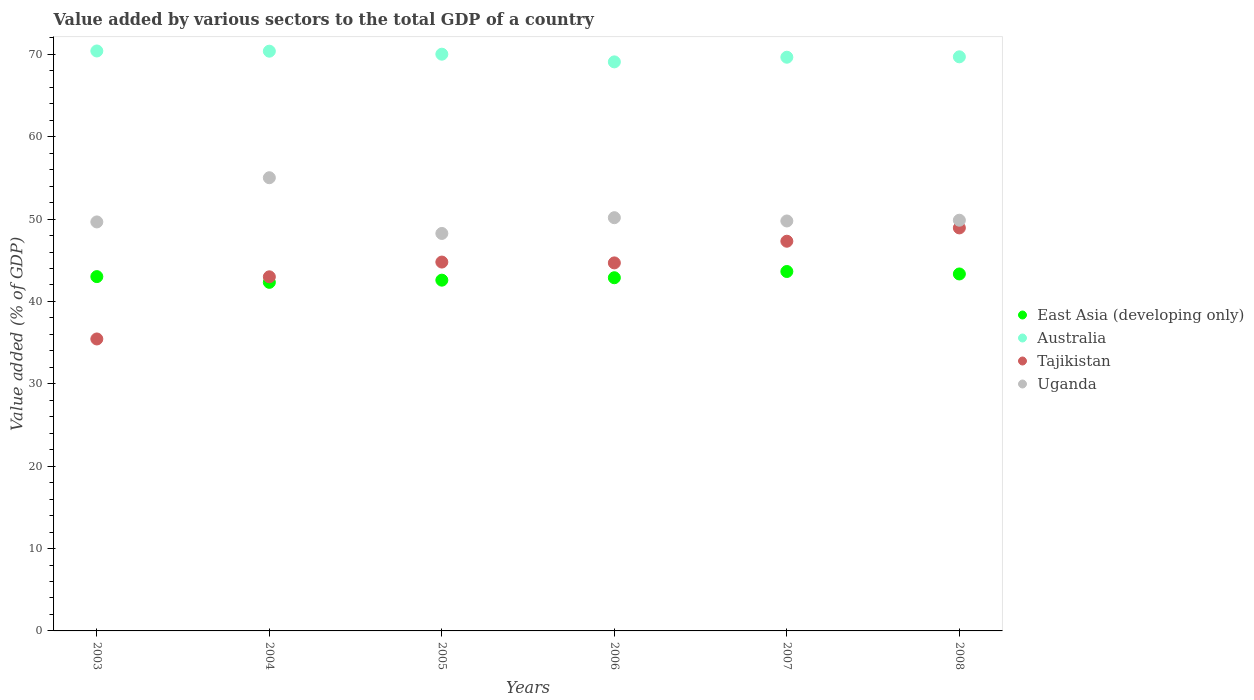What is the value added by various sectors to the total GDP in Tajikistan in 2008?
Offer a very short reply. 48.93. Across all years, what is the maximum value added by various sectors to the total GDP in Australia?
Give a very brief answer. 70.41. Across all years, what is the minimum value added by various sectors to the total GDP in East Asia (developing only)?
Provide a succinct answer. 42.32. What is the total value added by various sectors to the total GDP in Tajikistan in the graph?
Offer a terse response. 264.15. What is the difference between the value added by various sectors to the total GDP in Australia in 2004 and that in 2005?
Offer a very short reply. 0.36. What is the difference between the value added by various sectors to the total GDP in East Asia (developing only) in 2006 and the value added by various sectors to the total GDP in Tajikistan in 2005?
Ensure brevity in your answer.  -1.9. What is the average value added by various sectors to the total GDP in Uganda per year?
Give a very brief answer. 50.46. In the year 2005, what is the difference between the value added by various sectors to the total GDP in East Asia (developing only) and value added by various sectors to the total GDP in Australia?
Make the answer very short. -27.44. What is the ratio of the value added by various sectors to the total GDP in Uganda in 2003 to that in 2004?
Your answer should be compact. 0.9. Is the difference between the value added by various sectors to the total GDP in East Asia (developing only) in 2005 and 2007 greater than the difference between the value added by various sectors to the total GDP in Australia in 2005 and 2007?
Offer a terse response. No. What is the difference between the highest and the second highest value added by various sectors to the total GDP in East Asia (developing only)?
Offer a terse response. 0.3. What is the difference between the highest and the lowest value added by various sectors to the total GDP in Australia?
Your answer should be compact. 1.32. In how many years, is the value added by various sectors to the total GDP in Tajikistan greater than the average value added by various sectors to the total GDP in Tajikistan taken over all years?
Give a very brief answer. 4. Is it the case that in every year, the sum of the value added by various sectors to the total GDP in Uganda and value added by various sectors to the total GDP in Australia  is greater than the sum of value added by various sectors to the total GDP in East Asia (developing only) and value added by various sectors to the total GDP in Tajikistan?
Offer a very short reply. No. Is it the case that in every year, the sum of the value added by various sectors to the total GDP in Australia and value added by various sectors to the total GDP in Uganda  is greater than the value added by various sectors to the total GDP in East Asia (developing only)?
Your answer should be compact. Yes. Does the value added by various sectors to the total GDP in Australia monotonically increase over the years?
Offer a terse response. No. Is the value added by various sectors to the total GDP in East Asia (developing only) strictly less than the value added by various sectors to the total GDP in Tajikistan over the years?
Your response must be concise. No. How many dotlines are there?
Keep it short and to the point. 4. How many years are there in the graph?
Offer a very short reply. 6. Are the values on the major ticks of Y-axis written in scientific E-notation?
Make the answer very short. No. Does the graph contain grids?
Offer a terse response. No. How many legend labels are there?
Your answer should be very brief. 4. How are the legend labels stacked?
Provide a short and direct response. Vertical. What is the title of the graph?
Offer a terse response. Value added by various sectors to the total GDP of a country. What is the label or title of the Y-axis?
Offer a very short reply. Value added (% of GDP). What is the Value added (% of GDP) of East Asia (developing only) in 2003?
Provide a short and direct response. 43.02. What is the Value added (% of GDP) of Australia in 2003?
Provide a succinct answer. 70.41. What is the Value added (% of GDP) of Tajikistan in 2003?
Provide a short and direct response. 35.45. What is the Value added (% of GDP) in Uganda in 2003?
Give a very brief answer. 49.66. What is the Value added (% of GDP) in East Asia (developing only) in 2004?
Provide a short and direct response. 42.32. What is the Value added (% of GDP) in Australia in 2004?
Your response must be concise. 70.39. What is the Value added (% of GDP) in Tajikistan in 2004?
Provide a succinct answer. 42.99. What is the Value added (% of GDP) in Uganda in 2004?
Provide a succinct answer. 55.02. What is the Value added (% of GDP) of East Asia (developing only) in 2005?
Keep it short and to the point. 42.59. What is the Value added (% of GDP) in Australia in 2005?
Make the answer very short. 70.02. What is the Value added (% of GDP) of Tajikistan in 2005?
Your response must be concise. 44.78. What is the Value added (% of GDP) of Uganda in 2005?
Make the answer very short. 48.26. What is the Value added (% of GDP) in East Asia (developing only) in 2006?
Your answer should be compact. 42.88. What is the Value added (% of GDP) in Australia in 2006?
Your answer should be very brief. 69.09. What is the Value added (% of GDP) in Tajikistan in 2006?
Provide a succinct answer. 44.68. What is the Value added (% of GDP) in Uganda in 2006?
Offer a terse response. 50.17. What is the Value added (% of GDP) in East Asia (developing only) in 2007?
Your answer should be very brief. 43.64. What is the Value added (% of GDP) in Australia in 2007?
Your answer should be very brief. 69.65. What is the Value added (% of GDP) in Tajikistan in 2007?
Provide a short and direct response. 47.31. What is the Value added (% of GDP) in Uganda in 2007?
Offer a terse response. 49.77. What is the Value added (% of GDP) of East Asia (developing only) in 2008?
Your answer should be compact. 43.34. What is the Value added (% of GDP) of Australia in 2008?
Provide a short and direct response. 69.7. What is the Value added (% of GDP) in Tajikistan in 2008?
Your answer should be very brief. 48.93. What is the Value added (% of GDP) in Uganda in 2008?
Your answer should be very brief. 49.86. Across all years, what is the maximum Value added (% of GDP) of East Asia (developing only)?
Your answer should be very brief. 43.64. Across all years, what is the maximum Value added (% of GDP) of Australia?
Provide a succinct answer. 70.41. Across all years, what is the maximum Value added (% of GDP) of Tajikistan?
Your answer should be very brief. 48.93. Across all years, what is the maximum Value added (% of GDP) of Uganda?
Provide a succinct answer. 55.02. Across all years, what is the minimum Value added (% of GDP) in East Asia (developing only)?
Your response must be concise. 42.32. Across all years, what is the minimum Value added (% of GDP) of Australia?
Provide a short and direct response. 69.09. Across all years, what is the minimum Value added (% of GDP) in Tajikistan?
Give a very brief answer. 35.45. Across all years, what is the minimum Value added (% of GDP) in Uganda?
Give a very brief answer. 48.26. What is the total Value added (% of GDP) in East Asia (developing only) in the graph?
Ensure brevity in your answer.  257.78. What is the total Value added (% of GDP) in Australia in the graph?
Keep it short and to the point. 419.26. What is the total Value added (% of GDP) of Tajikistan in the graph?
Offer a terse response. 264.15. What is the total Value added (% of GDP) in Uganda in the graph?
Offer a very short reply. 302.74. What is the difference between the Value added (% of GDP) of East Asia (developing only) in 2003 and that in 2004?
Provide a short and direct response. 0.7. What is the difference between the Value added (% of GDP) in Australia in 2003 and that in 2004?
Ensure brevity in your answer.  0.03. What is the difference between the Value added (% of GDP) in Tajikistan in 2003 and that in 2004?
Your answer should be compact. -7.55. What is the difference between the Value added (% of GDP) in Uganda in 2003 and that in 2004?
Provide a succinct answer. -5.37. What is the difference between the Value added (% of GDP) of East Asia (developing only) in 2003 and that in 2005?
Ensure brevity in your answer.  0.43. What is the difference between the Value added (% of GDP) in Australia in 2003 and that in 2005?
Make the answer very short. 0.39. What is the difference between the Value added (% of GDP) in Tajikistan in 2003 and that in 2005?
Offer a terse response. -9.34. What is the difference between the Value added (% of GDP) in Uganda in 2003 and that in 2005?
Your response must be concise. 1.4. What is the difference between the Value added (% of GDP) in East Asia (developing only) in 2003 and that in 2006?
Your response must be concise. 0.14. What is the difference between the Value added (% of GDP) of Australia in 2003 and that in 2006?
Keep it short and to the point. 1.32. What is the difference between the Value added (% of GDP) of Tajikistan in 2003 and that in 2006?
Offer a terse response. -9.24. What is the difference between the Value added (% of GDP) of Uganda in 2003 and that in 2006?
Ensure brevity in your answer.  -0.51. What is the difference between the Value added (% of GDP) of East Asia (developing only) in 2003 and that in 2007?
Provide a succinct answer. -0.62. What is the difference between the Value added (% of GDP) in Australia in 2003 and that in 2007?
Your answer should be very brief. 0.76. What is the difference between the Value added (% of GDP) in Tajikistan in 2003 and that in 2007?
Offer a very short reply. -11.87. What is the difference between the Value added (% of GDP) in Uganda in 2003 and that in 2007?
Your answer should be compact. -0.12. What is the difference between the Value added (% of GDP) of East Asia (developing only) in 2003 and that in 2008?
Offer a terse response. -0.32. What is the difference between the Value added (% of GDP) in Australia in 2003 and that in 2008?
Your answer should be very brief. 0.71. What is the difference between the Value added (% of GDP) of Tajikistan in 2003 and that in 2008?
Offer a terse response. -13.48. What is the difference between the Value added (% of GDP) in Uganda in 2003 and that in 2008?
Provide a succinct answer. -0.21. What is the difference between the Value added (% of GDP) in East Asia (developing only) in 2004 and that in 2005?
Your response must be concise. -0.27. What is the difference between the Value added (% of GDP) of Australia in 2004 and that in 2005?
Give a very brief answer. 0.36. What is the difference between the Value added (% of GDP) of Tajikistan in 2004 and that in 2005?
Give a very brief answer. -1.79. What is the difference between the Value added (% of GDP) in Uganda in 2004 and that in 2005?
Offer a very short reply. 6.76. What is the difference between the Value added (% of GDP) of East Asia (developing only) in 2004 and that in 2006?
Your answer should be very brief. -0.56. What is the difference between the Value added (% of GDP) in Australia in 2004 and that in 2006?
Offer a terse response. 1.3. What is the difference between the Value added (% of GDP) of Tajikistan in 2004 and that in 2006?
Offer a terse response. -1.69. What is the difference between the Value added (% of GDP) of Uganda in 2004 and that in 2006?
Provide a succinct answer. 4.85. What is the difference between the Value added (% of GDP) of East Asia (developing only) in 2004 and that in 2007?
Your answer should be compact. -1.32. What is the difference between the Value added (% of GDP) in Australia in 2004 and that in 2007?
Offer a terse response. 0.73. What is the difference between the Value added (% of GDP) of Tajikistan in 2004 and that in 2007?
Offer a very short reply. -4.32. What is the difference between the Value added (% of GDP) of Uganda in 2004 and that in 2007?
Offer a very short reply. 5.25. What is the difference between the Value added (% of GDP) in East Asia (developing only) in 2004 and that in 2008?
Your answer should be very brief. -1.02. What is the difference between the Value added (% of GDP) in Australia in 2004 and that in 2008?
Make the answer very short. 0.68. What is the difference between the Value added (% of GDP) of Tajikistan in 2004 and that in 2008?
Give a very brief answer. -5.94. What is the difference between the Value added (% of GDP) of Uganda in 2004 and that in 2008?
Give a very brief answer. 5.16. What is the difference between the Value added (% of GDP) of East Asia (developing only) in 2005 and that in 2006?
Make the answer very short. -0.29. What is the difference between the Value added (% of GDP) in Australia in 2005 and that in 2006?
Your answer should be very brief. 0.93. What is the difference between the Value added (% of GDP) of Tajikistan in 2005 and that in 2006?
Offer a very short reply. 0.1. What is the difference between the Value added (% of GDP) of Uganda in 2005 and that in 2006?
Give a very brief answer. -1.91. What is the difference between the Value added (% of GDP) of East Asia (developing only) in 2005 and that in 2007?
Make the answer very short. -1.05. What is the difference between the Value added (% of GDP) of Australia in 2005 and that in 2007?
Offer a terse response. 0.37. What is the difference between the Value added (% of GDP) of Tajikistan in 2005 and that in 2007?
Your answer should be compact. -2.53. What is the difference between the Value added (% of GDP) in Uganda in 2005 and that in 2007?
Ensure brevity in your answer.  -1.52. What is the difference between the Value added (% of GDP) of East Asia (developing only) in 2005 and that in 2008?
Provide a succinct answer. -0.75. What is the difference between the Value added (% of GDP) of Australia in 2005 and that in 2008?
Provide a succinct answer. 0.32. What is the difference between the Value added (% of GDP) in Tajikistan in 2005 and that in 2008?
Ensure brevity in your answer.  -4.15. What is the difference between the Value added (% of GDP) in Uganda in 2005 and that in 2008?
Provide a succinct answer. -1.61. What is the difference between the Value added (% of GDP) of East Asia (developing only) in 2006 and that in 2007?
Provide a succinct answer. -0.76. What is the difference between the Value added (% of GDP) of Australia in 2006 and that in 2007?
Give a very brief answer. -0.56. What is the difference between the Value added (% of GDP) in Tajikistan in 2006 and that in 2007?
Offer a terse response. -2.63. What is the difference between the Value added (% of GDP) in Uganda in 2006 and that in 2007?
Your answer should be compact. 0.4. What is the difference between the Value added (% of GDP) of East Asia (developing only) in 2006 and that in 2008?
Your answer should be very brief. -0.46. What is the difference between the Value added (% of GDP) in Australia in 2006 and that in 2008?
Your response must be concise. -0.61. What is the difference between the Value added (% of GDP) of Tajikistan in 2006 and that in 2008?
Your answer should be compact. -4.25. What is the difference between the Value added (% of GDP) in Uganda in 2006 and that in 2008?
Give a very brief answer. 0.31. What is the difference between the Value added (% of GDP) of East Asia (developing only) in 2007 and that in 2008?
Your answer should be very brief. 0.3. What is the difference between the Value added (% of GDP) in Australia in 2007 and that in 2008?
Your answer should be very brief. -0.05. What is the difference between the Value added (% of GDP) of Tajikistan in 2007 and that in 2008?
Offer a very short reply. -1.62. What is the difference between the Value added (% of GDP) in Uganda in 2007 and that in 2008?
Your answer should be very brief. -0.09. What is the difference between the Value added (% of GDP) in East Asia (developing only) in 2003 and the Value added (% of GDP) in Australia in 2004?
Provide a succinct answer. -27.37. What is the difference between the Value added (% of GDP) of East Asia (developing only) in 2003 and the Value added (% of GDP) of Tajikistan in 2004?
Offer a very short reply. 0.03. What is the difference between the Value added (% of GDP) in East Asia (developing only) in 2003 and the Value added (% of GDP) in Uganda in 2004?
Offer a very short reply. -12. What is the difference between the Value added (% of GDP) in Australia in 2003 and the Value added (% of GDP) in Tajikistan in 2004?
Ensure brevity in your answer.  27.42. What is the difference between the Value added (% of GDP) in Australia in 2003 and the Value added (% of GDP) in Uganda in 2004?
Provide a succinct answer. 15.39. What is the difference between the Value added (% of GDP) in Tajikistan in 2003 and the Value added (% of GDP) in Uganda in 2004?
Make the answer very short. -19.58. What is the difference between the Value added (% of GDP) in East Asia (developing only) in 2003 and the Value added (% of GDP) in Australia in 2005?
Keep it short and to the point. -27. What is the difference between the Value added (% of GDP) in East Asia (developing only) in 2003 and the Value added (% of GDP) in Tajikistan in 2005?
Your response must be concise. -1.77. What is the difference between the Value added (% of GDP) of East Asia (developing only) in 2003 and the Value added (% of GDP) of Uganda in 2005?
Your response must be concise. -5.24. What is the difference between the Value added (% of GDP) in Australia in 2003 and the Value added (% of GDP) in Tajikistan in 2005?
Offer a terse response. 25.63. What is the difference between the Value added (% of GDP) in Australia in 2003 and the Value added (% of GDP) in Uganda in 2005?
Offer a very short reply. 22.15. What is the difference between the Value added (% of GDP) in Tajikistan in 2003 and the Value added (% of GDP) in Uganda in 2005?
Provide a succinct answer. -12.81. What is the difference between the Value added (% of GDP) in East Asia (developing only) in 2003 and the Value added (% of GDP) in Australia in 2006?
Give a very brief answer. -26.07. What is the difference between the Value added (% of GDP) of East Asia (developing only) in 2003 and the Value added (% of GDP) of Tajikistan in 2006?
Offer a terse response. -1.66. What is the difference between the Value added (% of GDP) in East Asia (developing only) in 2003 and the Value added (% of GDP) in Uganda in 2006?
Make the answer very short. -7.15. What is the difference between the Value added (% of GDP) in Australia in 2003 and the Value added (% of GDP) in Tajikistan in 2006?
Ensure brevity in your answer.  25.73. What is the difference between the Value added (% of GDP) of Australia in 2003 and the Value added (% of GDP) of Uganda in 2006?
Offer a very short reply. 20.24. What is the difference between the Value added (% of GDP) of Tajikistan in 2003 and the Value added (% of GDP) of Uganda in 2006?
Ensure brevity in your answer.  -14.72. What is the difference between the Value added (% of GDP) of East Asia (developing only) in 2003 and the Value added (% of GDP) of Australia in 2007?
Make the answer very short. -26.64. What is the difference between the Value added (% of GDP) of East Asia (developing only) in 2003 and the Value added (% of GDP) of Tajikistan in 2007?
Ensure brevity in your answer.  -4.3. What is the difference between the Value added (% of GDP) of East Asia (developing only) in 2003 and the Value added (% of GDP) of Uganda in 2007?
Offer a very short reply. -6.76. What is the difference between the Value added (% of GDP) in Australia in 2003 and the Value added (% of GDP) in Tajikistan in 2007?
Your answer should be compact. 23.1. What is the difference between the Value added (% of GDP) of Australia in 2003 and the Value added (% of GDP) of Uganda in 2007?
Provide a short and direct response. 20.64. What is the difference between the Value added (% of GDP) of Tajikistan in 2003 and the Value added (% of GDP) of Uganda in 2007?
Keep it short and to the point. -14.33. What is the difference between the Value added (% of GDP) in East Asia (developing only) in 2003 and the Value added (% of GDP) in Australia in 2008?
Provide a short and direct response. -26.68. What is the difference between the Value added (% of GDP) in East Asia (developing only) in 2003 and the Value added (% of GDP) in Tajikistan in 2008?
Ensure brevity in your answer.  -5.91. What is the difference between the Value added (% of GDP) of East Asia (developing only) in 2003 and the Value added (% of GDP) of Uganda in 2008?
Give a very brief answer. -6.85. What is the difference between the Value added (% of GDP) in Australia in 2003 and the Value added (% of GDP) in Tajikistan in 2008?
Make the answer very short. 21.48. What is the difference between the Value added (% of GDP) of Australia in 2003 and the Value added (% of GDP) of Uganda in 2008?
Your answer should be compact. 20.55. What is the difference between the Value added (% of GDP) of Tajikistan in 2003 and the Value added (% of GDP) of Uganda in 2008?
Your response must be concise. -14.42. What is the difference between the Value added (% of GDP) of East Asia (developing only) in 2004 and the Value added (% of GDP) of Australia in 2005?
Give a very brief answer. -27.7. What is the difference between the Value added (% of GDP) in East Asia (developing only) in 2004 and the Value added (% of GDP) in Tajikistan in 2005?
Offer a terse response. -2.46. What is the difference between the Value added (% of GDP) in East Asia (developing only) in 2004 and the Value added (% of GDP) in Uganda in 2005?
Your answer should be very brief. -5.94. What is the difference between the Value added (% of GDP) in Australia in 2004 and the Value added (% of GDP) in Tajikistan in 2005?
Make the answer very short. 25.6. What is the difference between the Value added (% of GDP) in Australia in 2004 and the Value added (% of GDP) in Uganda in 2005?
Your answer should be very brief. 22.13. What is the difference between the Value added (% of GDP) in Tajikistan in 2004 and the Value added (% of GDP) in Uganda in 2005?
Provide a succinct answer. -5.27. What is the difference between the Value added (% of GDP) of East Asia (developing only) in 2004 and the Value added (% of GDP) of Australia in 2006?
Ensure brevity in your answer.  -26.77. What is the difference between the Value added (% of GDP) of East Asia (developing only) in 2004 and the Value added (% of GDP) of Tajikistan in 2006?
Keep it short and to the point. -2.36. What is the difference between the Value added (% of GDP) of East Asia (developing only) in 2004 and the Value added (% of GDP) of Uganda in 2006?
Give a very brief answer. -7.85. What is the difference between the Value added (% of GDP) in Australia in 2004 and the Value added (% of GDP) in Tajikistan in 2006?
Offer a very short reply. 25.7. What is the difference between the Value added (% of GDP) in Australia in 2004 and the Value added (% of GDP) in Uganda in 2006?
Offer a terse response. 20.22. What is the difference between the Value added (% of GDP) of Tajikistan in 2004 and the Value added (% of GDP) of Uganda in 2006?
Your answer should be compact. -7.18. What is the difference between the Value added (% of GDP) in East Asia (developing only) in 2004 and the Value added (% of GDP) in Australia in 2007?
Your answer should be compact. -27.33. What is the difference between the Value added (% of GDP) of East Asia (developing only) in 2004 and the Value added (% of GDP) of Tajikistan in 2007?
Offer a terse response. -4.99. What is the difference between the Value added (% of GDP) in East Asia (developing only) in 2004 and the Value added (% of GDP) in Uganda in 2007?
Your answer should be compact. -7.45. What is the difference between the Value added (% of GDP) in Australia in 2004 and the Value added (% of GDP) in Tajikistan in 2007?
Your response must be concise. 23.07. What is the difference between the Value added (% of GDP) of Australia in 2004 and the Value added (% of GDP) of Uganda in 2007?
Offer a very short reply. 20.61. What is the difference between the Value added (% of GDP) of Tajikistan in 2004 and the Value added (% of GDP) of Uganda in 2007?
Offer a terse response. -6.78. What is the difference between the Value added (% of GDP) in East Asia (developing only) in 2004 and the Value added (% of GDP) in Australia in 2008?
Keep it short and to the point. -27.38. What is the difference between the Value added (% of GDP) in East Asia (developing only) in 2004 and the Value added (% of GDP) in Tajikistan in 2008?
Keep it short and to the point. -6.61. What is the difference between the Value added (% of GDP) in East Asia (developing only) in 2004 and the Value added (% of GDP) in Uganda in 2008?
Your answer should be compact. -7.54. What is the difference between the Value added (% of GDP) in Australia in 2004 and the Value added (% of GDP) in Tajikistan in 2008?
Your answer should be very brief. 21.46. What is the difference between the Value added (% of GDP) in Australia in 2004 and the Value added (% of GDP) in Uganda in 2008?
Give a very brief answer. 20.52. What is the difference between the Value added (% of GDP) in Tajikistan in 2004 and the Value added (% of GDP) in Uganda in 2008?
Your response must be concise. -6.87. What is the difference between the Value added (% of GDP) in East Asia (developing only) in 2005 and the Value added (% of GDP) in Australia in 2006?
Offer a terse response. -26.5. What is the difference between the Value added (% of GDP) of East Asia (developing only) in 2005 and the Value added (% of GDP) of Tajikistan in 2006?
Your response must be concise. -2.1. What is the difference between the Value added (% of GDP) of East Asia (developing only) in 2005 and the Value added (% of GDP) of Uganda in 2006?
Ensure brevity in your answer.  -7.58. What is the difference between the Value added (% of GDP) in Australia in 2005 and the Value added (% of GDP) in Tajikistan in 2006?
Provide a succinct answer. 25.34. What is the difference between the Value added (% of GDP) of Australia in 2005 and the Value added (% of GDP) of Uganda in 2006?
Provide a short and direct response. 19.85. What is the difference between the Value added (% of GDP) of Tajikistan in 2005 and the Value added (% of GDP) of Uganda in 2006?
Your answer should be very brief. -5.39. What is the difference between the Value added (% of GDP) in East Asia (developing only) in 2005 and the Value added (% of GDP) in Australia in 2007?
Offer a very short reply. -27.07. What is the difference between the Value added (% of GDP) in East Asia (developing only) in 2005 and the Value added (% of GDP) in Tajikistan in 2007?
Keep it short and to the point. -4.73. What is the difference between the Value added (% of GDP) in East Asia (developing only) in 2005 and the Value added (% of GDP) in Uganda in 2007?
Your answer should be compact. -7.19. What is the difference between the Value added (% of GDP) in Australia in 2005 and the Value added (% of GDP) in Tajikistan in 2007?
Offer a very short reply. 22.71. What is the difference between the Value added (% of GDP) of Australia in 2005 and the Value added (% of GDP) of Uganda in 2007?
Make the answer very short. 20.25. What is the difference between the Value added (% of GDP) of Tajikistan in 2005 and the Value added (% of GDP) of Uganda in 2007?
Make the answer very short. -4.99. What is the difference between the Value added (% of GDP) in East Asia (developing only) in 2005 and the Value added (% of GDP) in Australia in 2008?
Provide a short and direct response. -27.12. What is the difference between the Value added (% of GDP) in East Asia (developing only) in 2005 and the Value added (% of GDP) in Tajikistan in 2008?
Ensure brevity in your answer.  -6.34. What is the difference between the Value added (% of GDP) of East Asia (developing only) in 2005 and the Value added (% of GDP) of Uganda in 2008?
Offer a very short reply. -7.28. What is the difference between the Value added (% of GDP) of Australia in 2005 and the Value added (% of GDP) of Tajikistan in 2008?
Provide a succinct answer. 21.09. What is the difference between the Value added (% of GDP) in Australia in 2005 and the Value added (% of GDP) in Uganda in 2008?
Keep it short and to the point. 20.16. What is the difference between the Value added (% of GDP) in Tajikistan in 2005 and the Value added (% of GDP) in Uganda in 2008?
Ensure brevity in your answer.  -5.08. What is the difference between the Value added (% of GDP) in East Asia (developing only) in 2006 and the Value added (% of GDP) in Australia in 2007?
Provide a short and direct response. -26.77. What is the difference between the Value added (% of GDP) of East Asia (developing only) in 2006 and the Value added (% of GDP) of Tajikistan in 2007?
Offer a terse response. -4.43. What is the difference between the Value added (% of GDP) of East Asia (developing only) in 2006 and the Value added (% of GDP) of Uganda in 2007?
Your answer should be compact. -6.89. What is the difference between the Value added (% of GDP) of Australia in 2006 and the Value added (% of GDP) of Tajikistan in 2007?
Provide a succinct answer. 21.77. What is the difference between the Value added (% of GDP) in Australia in 2006 and the Value added (% of GDP) in Uganda in 2007?
Keep it short and to the point. 19.32. What is the difference between the Value added (% of GDP) of Tajikistan in 2006 and the Value added (% of GDP) of Uganda in 2007?
Give a very brief answer. -5.09. What is the difference between the Value added (% of GDP) in East Asia (developing only) in 2006 and the Value added (% of GDP) in Australia in 2008?
Your answer should be very brief. -26.82. What is the difference between the Value added (% of GDP) in East Asia (developing only) in 2006 and the Value added (% of GDP) in Tajikistan in 2008?
Your response must be concise. -6.05. What is the difference between the Value added (% of GDP) of East Asia (developing only) in 2006 and the Value added (% of GDP) of Uganda in 2008?
Offer a very short reply. -6.98. What is the difference between the Value added (% of GDP) of Australia in 2006 and the Value added (% of GDP) of Tajikistan in 2008?
Keep it short and to the point. 20.16. What is the difference between the Value added (% of GDP) in Australia in 2006 and the Value added (% of GDP) in Uganda in 2008?
Ensure brevity in your answer.  19.22. What is the difference between the Value added (% of GDP) of Tajikistan in 2006 and the Value added (% of GDP) of Uganda in 2008?
Your answer should be very brief. -5.18. What is the difference between the Value added (% of GDP) of East Asia (developing only) in 2007 and the Value added (% of GDP) of Australia in 2008?
Offer a terse response. -26.06. What is the difference between the Value added (% of GDP) of East Asia (developing only) in 2007 and the Value added (% of GDP) of Tajikistan in 2008?
Offer a terse response. -5.29. What is the difference between the Value added (% of GDP) of East Asia (developing only) in 2007 and the Value added (% of GDP) of Uganda in 2008?
Ensure brevity in your answer.  -6.23. What is the difference between the Value added (% of GDP) in Australia in 2007 and the Value added (% of GDP) in Tajikistan in 2008?
Provide a short and direct response. 20.72. What is the difference between the Value added (% of GDP) in Australia in 2007 and the Value added (% of GDP) in Uganda in 2008?
Offer a terse response. 19.79. What is the difference between the Value added (% of GDP) of Tajikistan in 2007 and the Value added (% of GDP) of Uganda in 2008?
Your response must be concise. -2.55. What is the average Value added (% of GDP) of East Asia (developing only) per year?
Ensure brevity in your answer.  42.96. What is the average Value added (% of GDP) in Australia per year?
Provide a succinct answer. 69.88. What is the average Value added (% of GDP) in Tajikistan per year?
Give a very brief answer. 44.02. What is the average Value added (% of GDP) in Uganda per year?
Your answer should be very brief. 50.46. In the year 2003, what is the difference between the Value added (% of GDP) in East Asia (developing only) and Value added (% of GDP) in Australia?
Your response must be concise. -27.39. In the year 2003, what is the difference between the Value added (% of GDP) in East Asia (developing only) and Value added (% of GDP) in Tajikistan?
Keep it short and to the point. 7.57. In the year 2003, what is the difference between the Value added (% of GDP) in East Asia (developing only) and Value added (% of GDP) in Uganda?
Provide a short and direct response. -6.64. In the year 2003, what is the difference between the Value added (% of GDP) of Australia and Value added (% of GDP) of Tajikistan?
Provide a short and direct response. 34.97. In the year 2003, what is the difference between the Value added (% of GDP) in Australia and Value added (% of GDP) in Uganda?
Offer a very short reply. 20.76. In the year 2003, what is the difference between the Value added (% of GDP) in Tajikistan and Value added (% of GDP) in Uganda?
Your answer should be compact. -14.21. In the year 2004, what is the difference between the Value added (% of GDP) in East Asia (developing only) and Value added (% of GDP) in Australia?
Your answer should be very brief. -28.07. In the year 2004, what is the difference between the Value added (% of GDP) of East Asia (developing only) and Value added (% of GDP) of Tajikistan?
Offer a very short reply. -0.67. In the year 2004, what is the difference between the Value added (% of GDP) in East Asia (developing only) and Value added (% of GDP) in Uganda?
Give a very brief answer. -12.7. In the year 2004, what is the difference between the Value added (% of GDP) in Australia and Value added (% of GDP) in Tajikistan?
Offer a terse response. 27.39. In the year 2004, what is the difference between the Value added (% of GDP) of Australia and Value added (% of GDP) of Uganda?
Your answer should be very brief. 15.36. In the year 2004, what is the difference between the Value added (% of GDP) in Tajikistan and Value added (% of GDP) in Uganda?
Provide a succinct answer. -12.03. In the year 2005, what is the difference between the Value added (% of GDP) in East Asia (developing only) and Value added (% of GDP) in Australia?
Keep it short and to the point. -27.43. In the year 2005, what is the difference between the Value added (% of GDP) in East Asia (developing only) and Value added (% of GDP) in Tajikistan?
Ensure brevity in your answer.  -2.2. In the year 2005, what is the difference between the Value added (% of GDP) in East Asia (developing only) and Value added (% of GDP) in Uganda?
Offer a very short reply. -5.67. In the year 2005, what is the difference between the Value added (% of GDP) of Australia and Value added (% of GDP) of Tajikistan?
Offer a terse response. 25.24. In the year 2005, what is the difference between the Value added (% of GDP) of Australia and Value added (% of GDP) of Uganda?
Make the answer very short. 21.76. In the year 2005, what is the difference between the Value added (% of GDP) in Tajikistan and Value added (% of GDP) in Uganda?
Your response must be concise. -3.47. In the year 2006, what is the difference between the Value added (% of GDP) of East Asia (developing only) and Value added (% of GDP) of Australia?
Offer a terse response. -26.21. In the year 2006, what is the difference between the Value added (% of GDP) in East Asia (developing only) and Value added (% of GDP) in Tajikistan?
Keep it short and to the point. -1.8. In the year 2006, what is the difference between the Value added (% of GDP) in East Asia (developing only) and Value added (% of GDP) in Uganda?
Offer a terse response. -7.29. In the year 2006, what is the difference between the Value added (% of GDP) of Australia and Value added (% of GDP) of Tajikistan?
Provide a succinct answer. 24.41. In the year 2006, what is the difference between the Value added (% of GDP) of Australia and Value added (% of GDP) of Uganda?
Give a very brief answer. 18.92. In the year 2006, what is the difference between the Value added (% of GDP) in Tajikistan and Value added (% of GDP) in Uganda?
Provide a succinct answer. -5.49. In the year 2007, what is the difference between the Value added (% of GDP) in East Asia (developing only) and Value added (% of GDP) in Australia?
Provide a succinct answer. -26.02. In the year 2007, what is the difference between the Value added (% of GDP) in East Asia (developing only) and Value added (% of GDP) in Tajikistan?
Keep it short and to the point. -3.68. In the year 2007, what is the difference between the Value added (% of GDP) of East Asia (developing only) and Value added (% of GDP) of Uganda?
Give a very brief answer. -6.14. In the year 2007, what is the difference between the Value added (% of GDP) of Australia and Value added (% of GDP) of Tajikistan?
Ensure brevity in your answer.  22.34. In the year 2007, what is the difference between the Value added (% of GDP) of Australia and Value added (% of GDP) of Uganda?
Provide a succinct answer. 19.88. In the year 2007, what is the difference between the Value added (% of GDP) of Tajikistan and Value added (% of GDP) of Uganda?
Your answer should be very brief. -2.46. In the year 2008, what is the difference between the Value added (% of GDP) of East Asia (developing only) and Value added (% of GDP) of Australia?
Your answer should be compact. -26.36. In the year 2008, what is the difference between the Value added (% of GDP) of East Asia (developing only) and Value added (% of GDP) of Tajikistan?
Provide a short and direct response. -5.59. In the year 2008, what is the difference between the Value added (% of GDP) in East Asia (developing only) and Value added (% of GDP) in Uganda?
Provide a succinct answer. -6.53. In the year 2008, what is the difference between the Value added (% of GDP) in Australia and Value added (% of GDP) in Tajikistan?
Your answer should be compact. 20.77. In the year 2008, what is the difference between the Value added (% of GDP) in Australia and Value added (% of GDP) in Uganda?
Provide a short and direct response. 19.84. In the year 2008, what is the difference between the Value added (% of GDP) of Tajikistan and Value added (% of GDP) of Uganda?
Keep it short and to the point. -0.93. What is the ratio of the Value added (% of GDP) of East Asia (developing only) in 2003 to that in 2004?
Provide a short and direct response. 1.02. What is the ratio of the Value added (% of GDP) of Australia in 2003 to that in 2004?
Make the answer very short. 1. What is the ratio of the Value added (% of GDP) in Tajikistan in 2003 to that in 2004?
Your answer should be very brief. 0.82. What is the ratio of the Value added (% of GDP) of Uganda in 2003 to that in 2004?
Your answer should be very brief. 0.9. What is the ratio of the Value added (% of GDP) in Australia in 2003 to that in 2005?
Offer a terse response. 1.01. What is the ratio of the Value added (% of GDP) of Tajikistan in 2003 to that in 2005?
Provide a succinct answer. 0.79. What is the ratio of the Value added (% of GDP) of Uganda in 2003 to that in 2005?
Make the answer very short. 1.03. What is the ratio of the Value added (% of GDP) of East Asia (developing only) in 2003 to that in 2006?
Provide a short and direct response. 1. What is the ratio of the Value added (% of GDP) of Australia in 2003 to that in 2006?
Give a very brief answer. 1.02. What is the ratio of the Value added (% of GDP) in Tajikistan in 2003 to that in 2006?
Give a very brief answer. 0.79. What is the ratio of the Value added (% of GDP) in East Asia (developing only) in 2003 to that in 2007?
Provide a short and direct response. 0.99. What is the ratio of the Value added (% of GDP) in Australia in 2003 to that in 2007?
Offer a very short reply. 1.01. What is the ratio of the Value added (% of GDP) in Tajikistan in 2003 to that in 2007?
Your answer should be very brief. 0.75. What is the ratio of the Value added (% of GDP) of East Asia (developing only) in 2003 to that in 2008?
Your answer should be compact. 0.99. What is the ratio of the Value added (% of GDP) in Australia in 2003 to that in 2008?
Offer a very short reply. 1.01. What is the ratio of the Value added (% of GDP) in Tajikistan in 2003 to that in 2008?
Your answer should be compact. 0.72. What is the ratio of the Value added (% of GDP) of Uganda in 2004 to that in 2005?
Your response must be concise. 1.14. What is the ratio of the Value added (% of GDP) in East Asia (developing only) in 2004 to that in 2006?
Make the answer very short. 0.99. What is the ratio of the Value added (% of GDP) of Australia in 2004 to that in 2006?
Offer a terse response. 1.02. What is the ratio of the Value added (% of GDP) of Tajikistan in 2004 to that in 2006?
Offer a terse response. 0.96. What is the ratio of the Value added (% of GDP) in Uganda in 2004 to that in 2006?
Make the answer very short. 1.1. What is the ratio of the Value added (% of GDP) of East Asia (developing only) in 2004 to that in 2007?
Provide a short and direct response. 0.97. What is the ratio of the Value added (% of GDP) in Australia in 2004 to that in 2007?
Make the answer very short. 1.01. What is the ratio of the Value added (% of GDP) in Tajikistan in 2004 to that in 2007?
Your answer should be very brief. 0.91. What is the ratio of the Value added (% of GDP) in Uganda in 2004 to that in 2007?
Ensure brevity in your answer.  1.11. What is the ratio of the Value added (% of GDP) of East Asia (developing only) in 2004 to that in 2008?
Ensure brevity in your answer.  0.98. What is the ratio of the Value added (% of GDP) of Australia in 2004 to that in 2008?
Give a very brief answer. 1.01. What is the ratio of the Value added (% of GDP) in Tajikistan in 2004 to that in 2008?
Ensure brevity in your answer.  0.88. What is the ratio of the Value added (% of GDP) of Uganda in 2004 to that in 2008?
Offer a terse response. 1.1. What is the ratio of the Value added (% of GDP) in East Asia (developing only) in 2005 to that in 2006?
Give a very brief answer. 0.99. What is the ratio of the Value added (% of GDP) of Australia in 2005 to that in 2006?
Provide a short and direct response. 1.01. What is the ratio of the Value added (% of GDP) of Tajikistan in 2005 to that in 2006?
Your answer should be compact. 1. What is the ratio of the Value added (% of GDP) in Uganda in 2005 to that in 2006?
Your answer should be very brief. 0.96. What is the ratio of the Value added (% of GDP) in East Asia (developing only) in 2005 to that in 2007?
Your answer should be compact. 0.98. What is the ratio of the Value added (% of GDP) in Australia in 2005 to that in 2007?
Provide a succinct answer. 1.01. What is the ratio of the Value added (% of GDP) of Tajikistan in 2005 to that in 2007?
Your response must be concise. 0.95. What is the ratio of the Value added (% of GDP) of Uganda in 2005 to that in 2007?
Your answer should be very brief. 0.97. What is the ratio of the Value added (% of GDP) of East Asia (developing only) in 2005 to that in 2008?
Offer a terse response. 0.98. What is the ratio of the Value added (% of GDP) of Tajikistan in 2005 to that in 2008?
Make the answer very short. 0.92. What is the ratio of the Value added (% of GDP) in Uganda in 2005 to that in 2008?
Offer a terse response. 0.97. What is the ratio of the Value added (% of GDP) of East Asia (developing only) in 2006 to that in 2007?
Give a very brief answer. 0.98. What is the ratio of the Value added (% of GDP) in East Asia (developing only) in 2006 to that in 2008?
Make the answer very short. 0.99. What is the ratio of the Value added (% of GDP) of Tajikistan in 2006 to that in 2008?
Provide a short and direct response. 0.91. What is the ratio of the Value added (% of GDP) of Uganda in 2007 to that in 2008?
Ensure brevity in your answer.  1. What is the difference between the highest and the second highest Value added (% of GDP) in East Asia (developing only)?
Offer a very short reply. 0.3. What is the difference between the highest and the second highest Value added (% of GDP) of Australia?
Keep it short and to the point. 0.03. What is the difference between the highest and the second highest Value added (% of GDP) of Tajikistan?
Keep it short and to the point. 1.62. What is the difference between the highest and the second highest Value added (% of GDP) in Uganda?
Make the answer very short. 4.85. What is the difference between the highest and the lowest Value added (% of GDP) of East Asia (developing only)?
Provide a short and direct response. 1.32. What is the difference between the highest and the lowest Value added (% of GDP) in Australia?
Your answer should be compact. 1.32. What is the difference between the highest and the lowest Value added (% of GDP) in Tajikistan?
Offer a very short reply. 13.48. What is the difference between the highest and the lowest Value added (% of GDP) of Uganda?
Give a very brief answer. 6.76. 